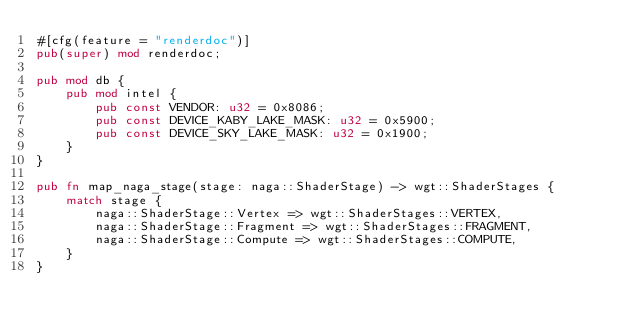Convert code to text. <code><loc_0><loc_0><loc_500><loc_500><_Rust_>#[cfg(feature = "renderdoc")]
pub(super) mod renderdoc;

pub mod db {
    pub mod intel {
        pub const VENDOR: u32 = 0x8086;
        pub const DEVICE_KABY_LAKE_MASK: u32 = 0x5900;
        pub const DEVICE_SKY_LAKE_MASK: u32 = 0x1900;
    }
}

pub fn map_naga_stage(stage: naga::ShaderStage) -> wgt::ShaderStages {
    match stage {
        naga::ShaderStage::Vertex => wgt::ShaderStages::VERTEX,
        naga::ShaderStage::Fragment => wgt::ShaderStages::FRAGMENT,
        naga::ShaderStage::Compute => wgt::ShaderStages::COMPUTE,
    }
}
</code> 